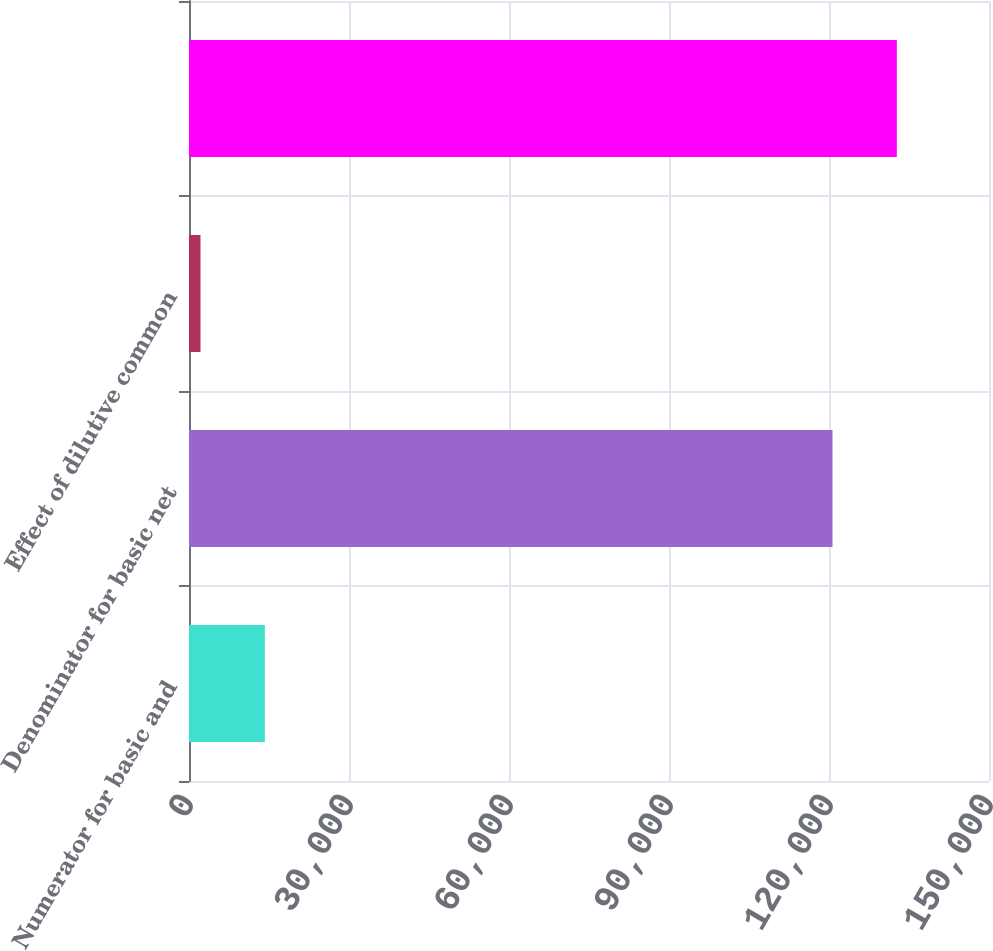Convert chart. <chart><loc_0><loc_0><loc_500><loc_500><bar_chart><fcel>Numerator for basic and<fcel>Denominator for basic net<fcel>Effect of dilutive common<fcel>Unnamed: 3<nl><fcel>14219.7<fcel>120657<fcel>2154<fcel>132723<nl></chart> 